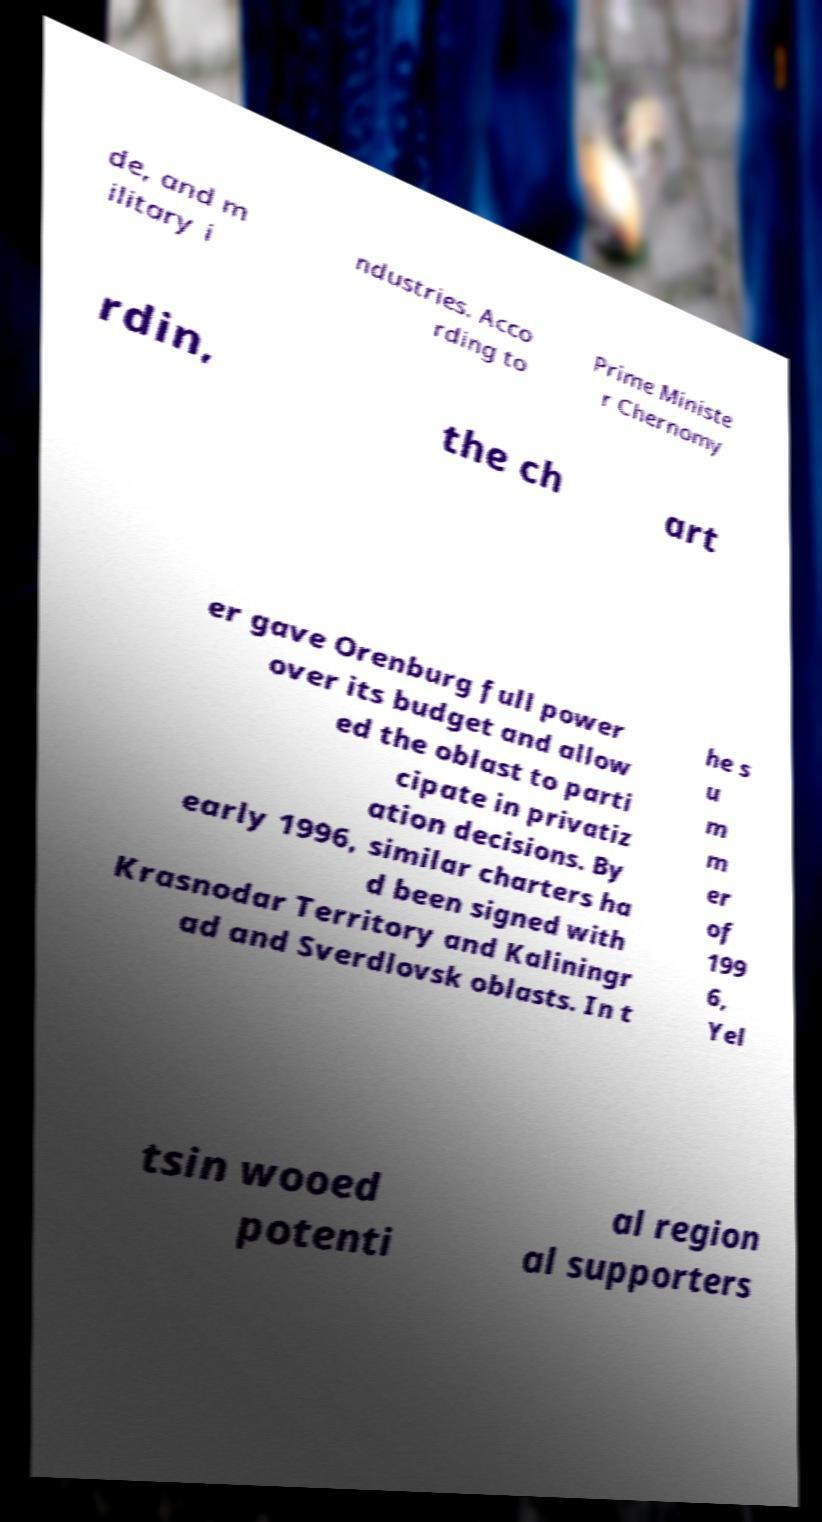Please read and relay the text visible in this image. What does it say? de, and m ilitary i ndustries. Acco rding to Prime Ministe r Chernomy rdin, the ch art er gave Orenburg full power over its budget and allow ed the oblast to parti cipate in privatiz ation decisions. By early 1996, similar charters ha d been signed with Krasnodar Territory and Kaliningr ad and Sverdlovsk oblasts. In t he s u m m er of 199 6, Yel tsin wooed potenti al region al supporters 